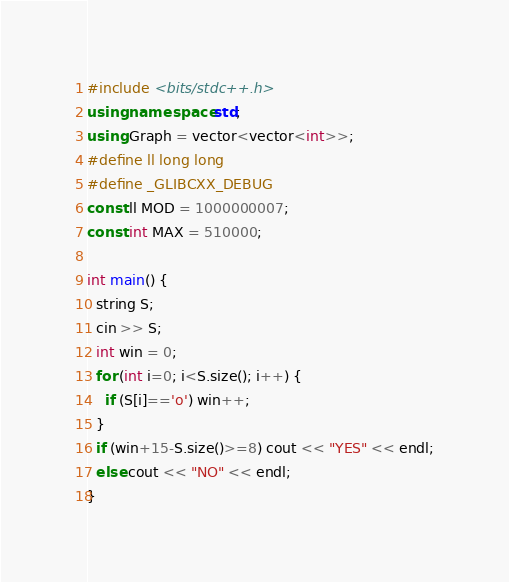<code> <loc_0><loc_0><loc_500><loc_500><_C++_>#include <bits/stdc++.h>
using namespace std;
using Graph = vector<vector<int>>;
#define ll long long
#define _GLIBCXX_DEBUG
const ll MOD = 1000000007;
const int MAX = 510000;

int main() {
  string S;
  cin >> S;
  int win = 0;
  for (int i=0; i<S.size(); i++) {
    if (S[i]=='o') win++;
  }
  if (win+15-S.size()>=8) cout << "YES" << endl;
  else cout << "NO" << endl;
}</code> 